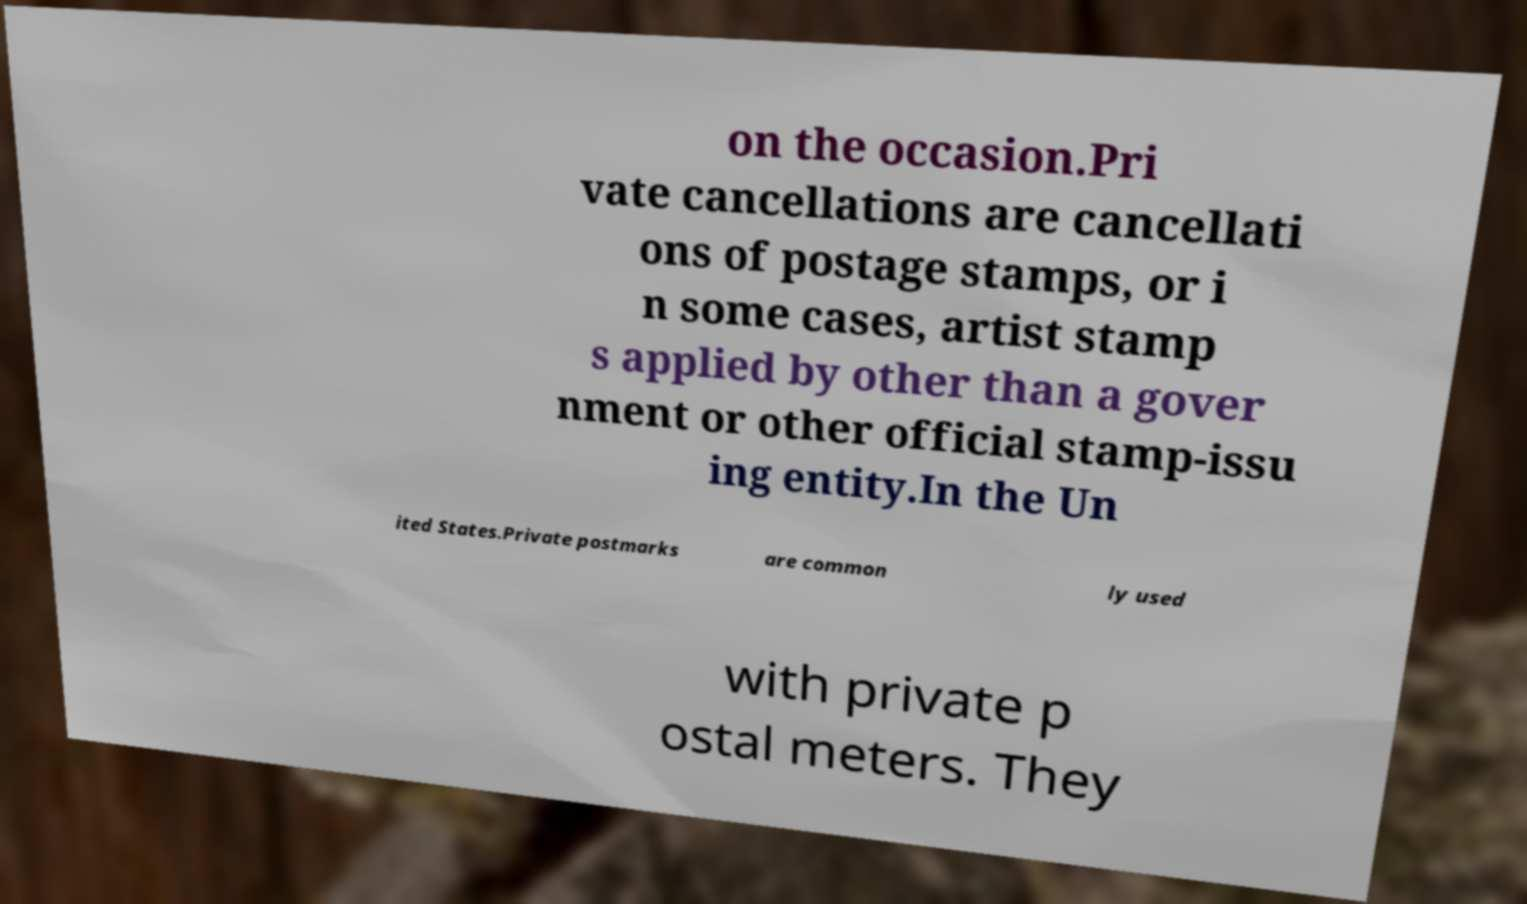Can you read and provide the text displayed in the image?This photo seems to have some interesting text. Can you extract and type it out for me? on the occasion.Pri vate cancellations are cancellati ons of postage stamps, or i n some cases, artist stamp s applied by other than a gover nment or other official stamp-issu ing entity.In the Un ited States.Private postmarks are common ly used with private p ostal meters. They 